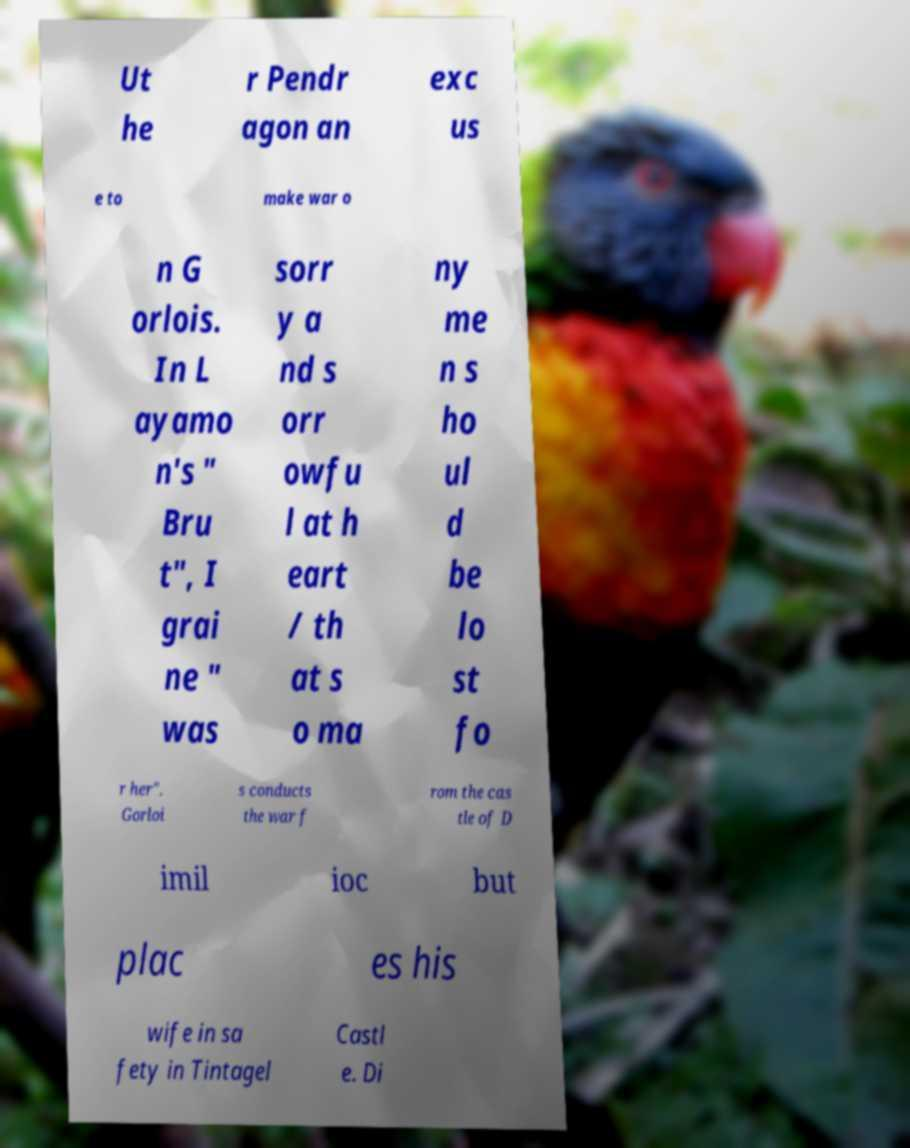Please read and relay the text visible in this image. What does it say? Ut he r Pendr agon an exc us e to make war o n G orlois. In L ayamo n's " Bru t", I grai ne " was sorr y a nd s orr owfu l at h eart / th at s o ma ny me n s ho ul d be lo st fo r her". Gorloi s conducts the war f rom the cas tle of D imil ioc but plac es his wife in sa fety in Tintagel Castl e. Di 